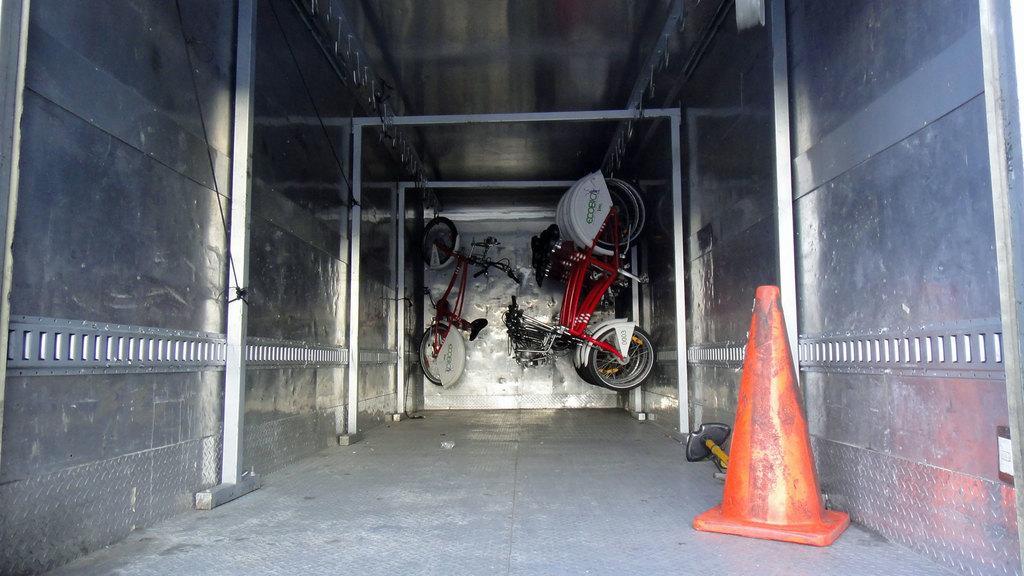Describe this image in one or two sentences. In this image few bicycles are hanged from the roof. Background there is a wall. Right side there is an inverted cone and few objects are on the floor. 